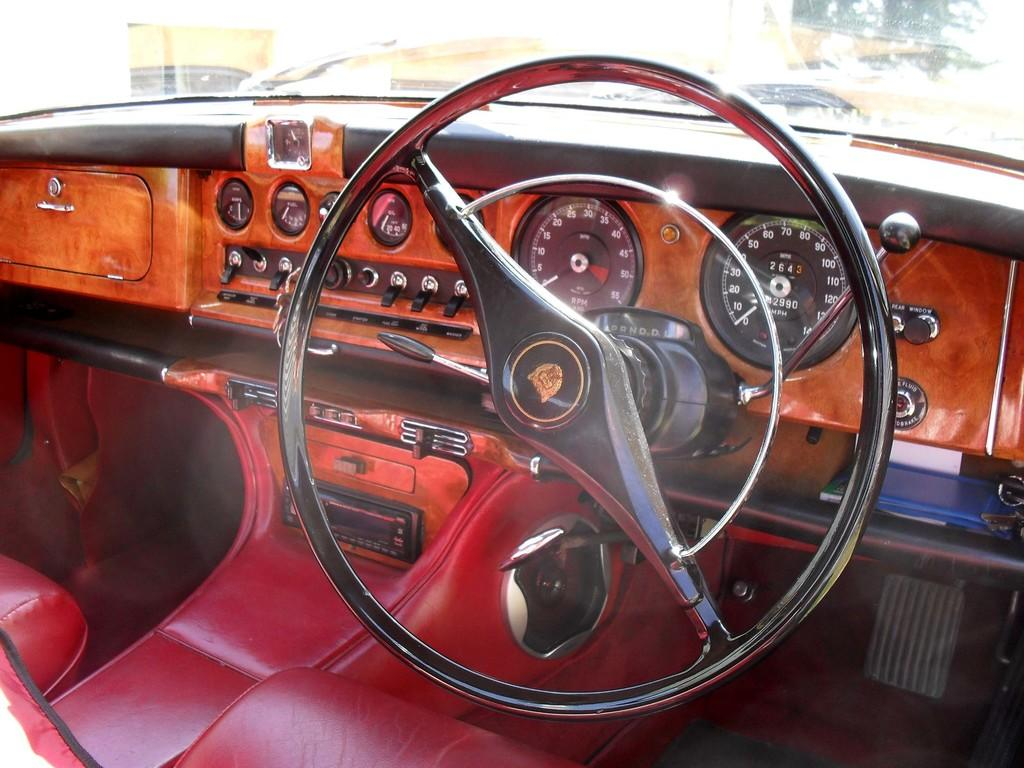What type of environment is depicted in the image? The image shows an inside view of a car. What is the main control device in the car? There is a steering wheel in the image. What are the seats used for in the car? The seats are used for passengers to sit in while traveling. What is the texture of the tongue visible in the image? There is no tongue present in the image. 